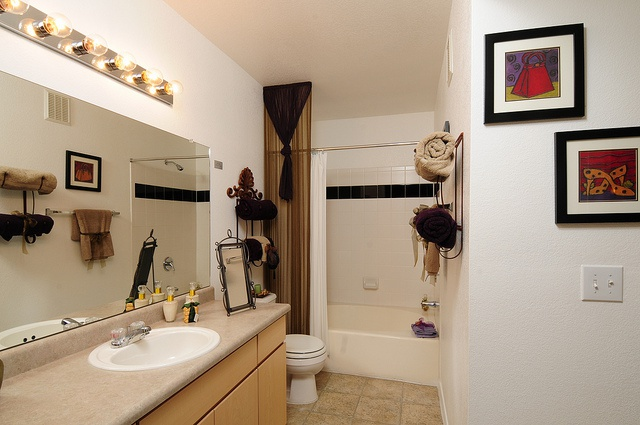Describe the objects in this image and their specific colors. I can see sink in gray, lightgray, tan, and darkgray tones, toilet in gray and tan tones, and cup in gray and tan tones in this image. 